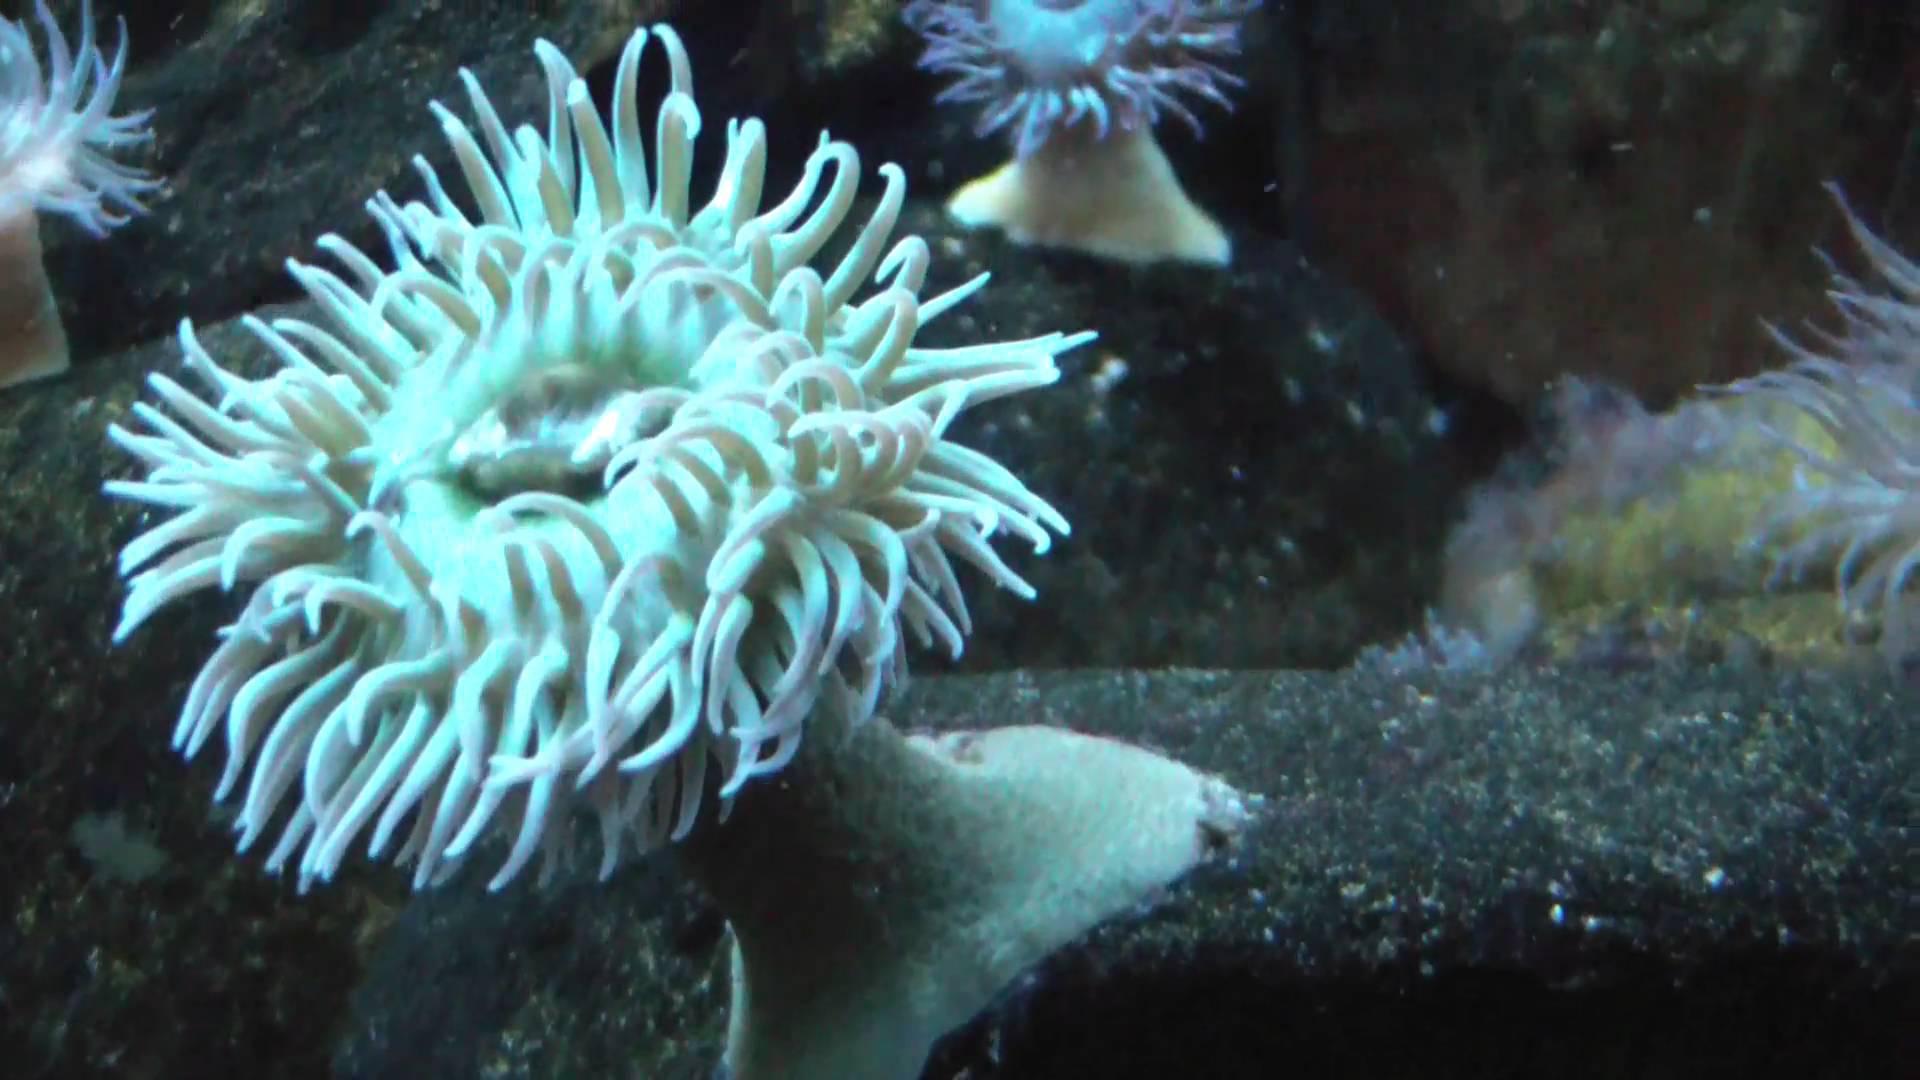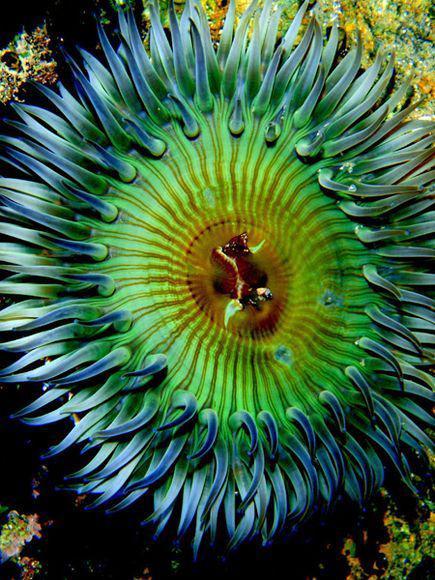The first image is the image on the left, the second image is the image on the right. Considering the images on both sides, is "The trunk of the anemone can be seen in the image on the left." valid? Answer yes or no. Yes. The first image is the image on the left, the second image is the image on the right. Given the left and right images, does the statement "The left image shows a white anemone with its mouth-like center visible." hold true? Answer yes or no. Yes. 